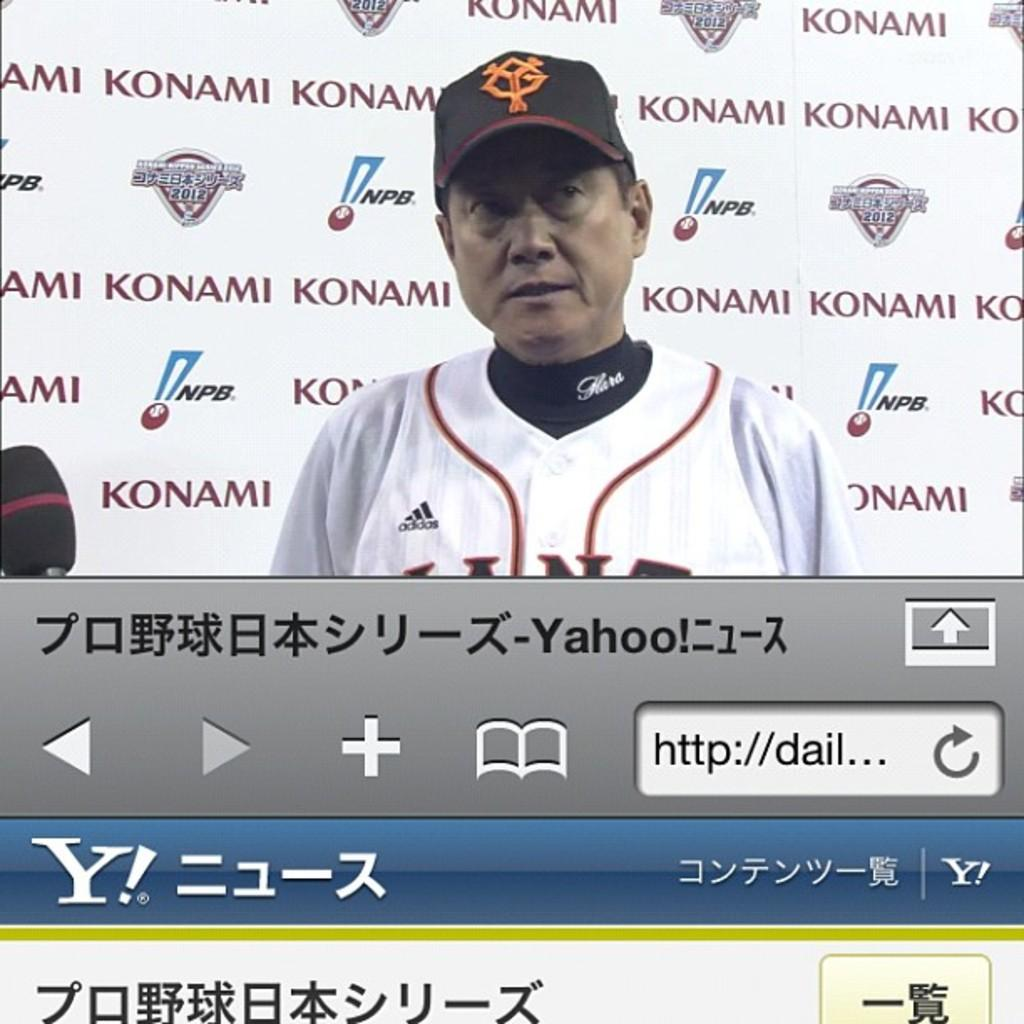<image>
Share a concise interpretation of the image provided. A web-page showing a man with an Adidas jersey 